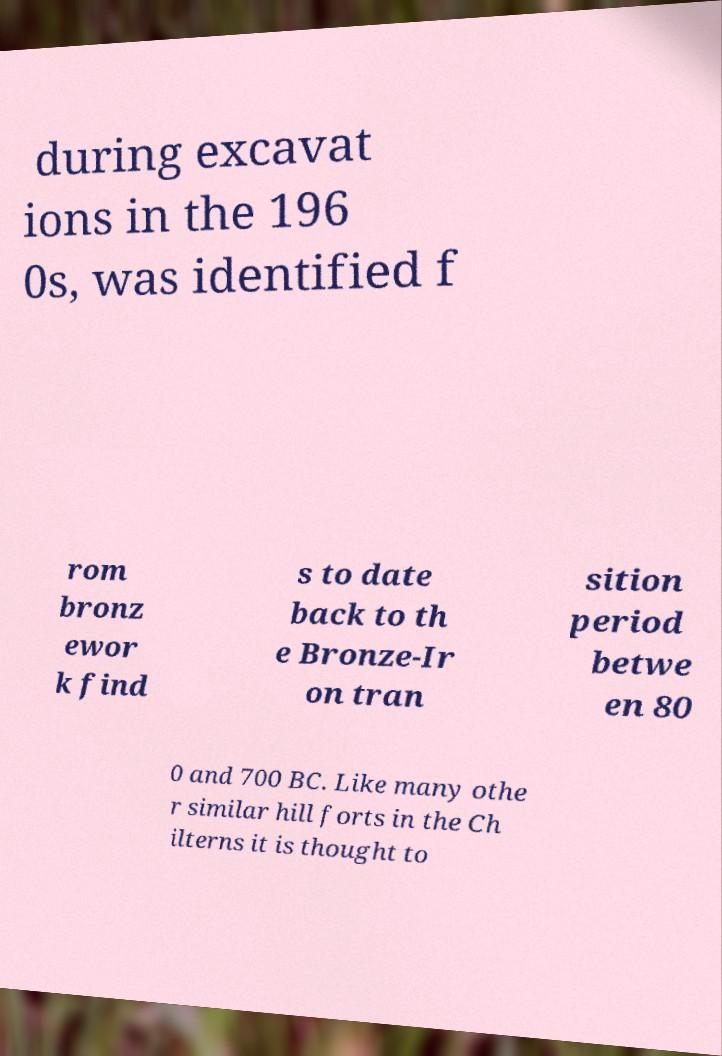There's text embedded in this image that I need extracted. Can you transcribe it verbatim? during excavat ions in the 196 0s, was identified f rom bronz ewor k find s to date back to th e Bronze-Ir on tran sition period betwe en 80 0 and 700 BC. Like many othe r similar hill forts in the Ch ilterns it is thought to 